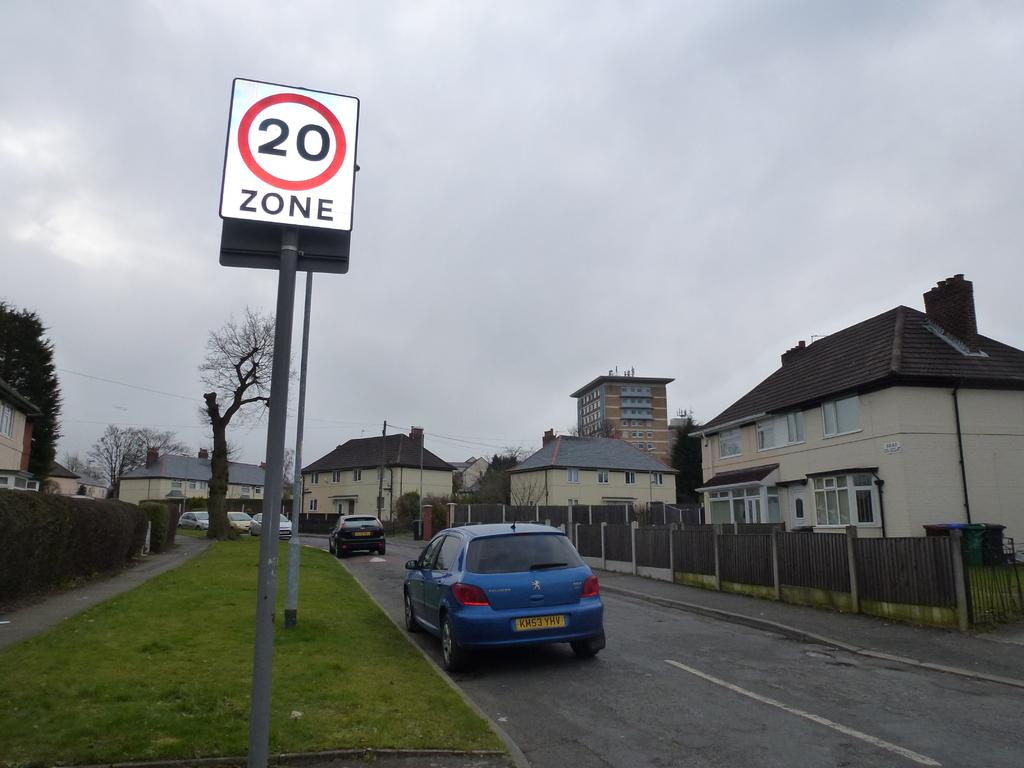<image>
Summarize the visual content of the image. A car is parked on a street next to a sign that says 20 zone. 